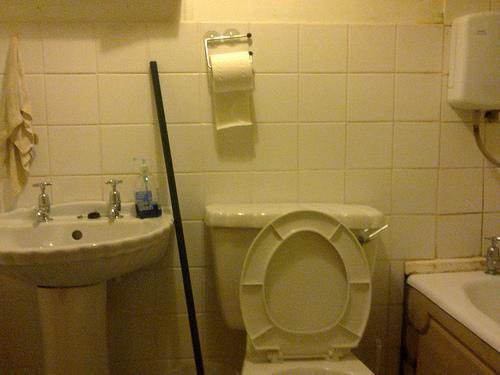How many toilets are there?
Give a very brief answer. 1. 